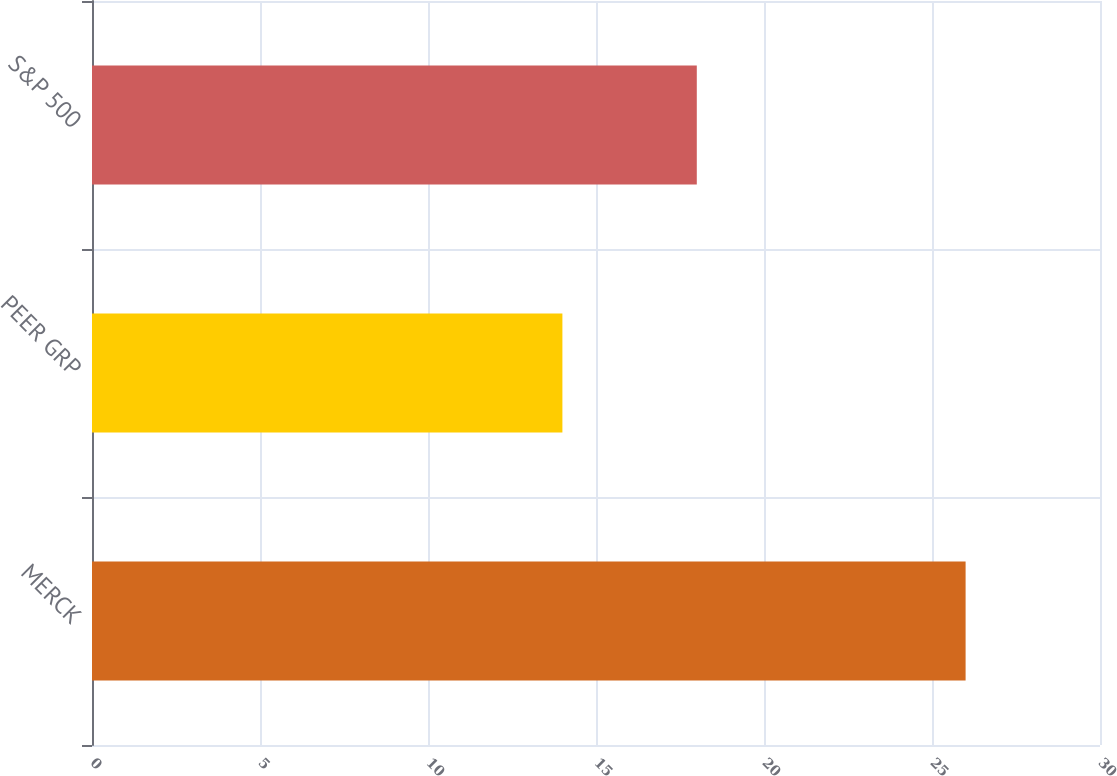Convert chart to OTSL. <chart><loc_0><loc_0><loc_500><loc_500><bar_chart><fcel>MERCK<fcel>PEER GRP<fcel>S&P 500<nl><fcel>26<fcel>14<fcel>18<nl></chart> 